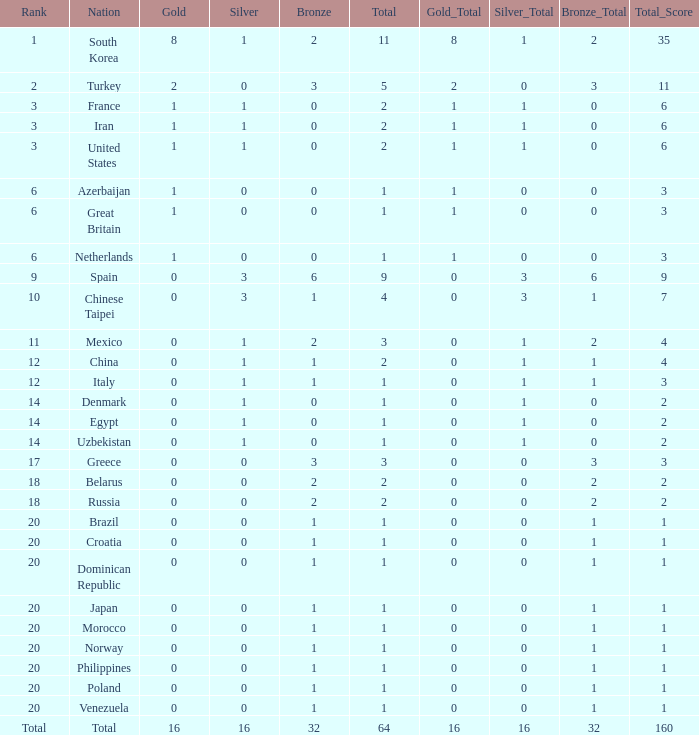What is the average total medals of the nation ranked 1 with less than 1 silver? None. 